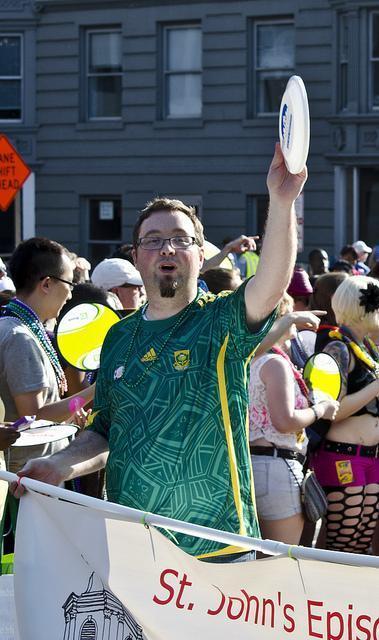How many people are there?
Give a very brief answer. 4. How many frisbees can you see?
Give a very brief answer. 2. How many cats are on the bench?
Give a very brief answer. 0. 